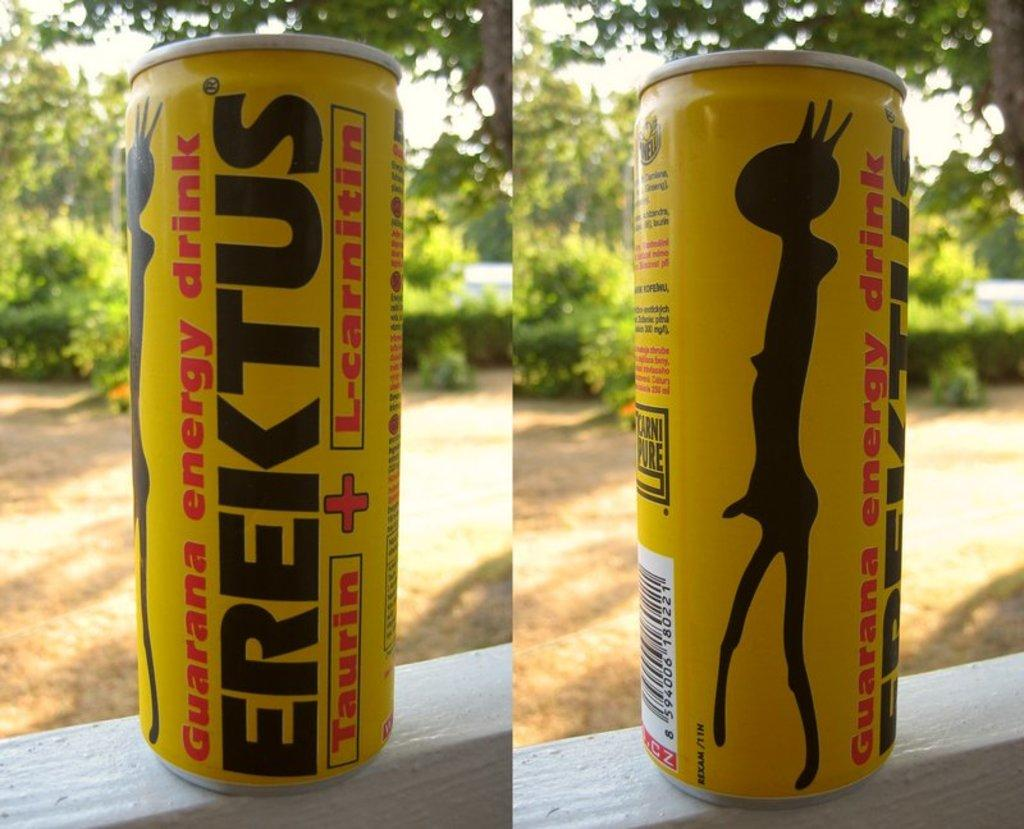<image>
Relay a brief, clear account of the picture shown. Both sides of an Erektus energy drink can that has taurin + L-carnitin in it. 